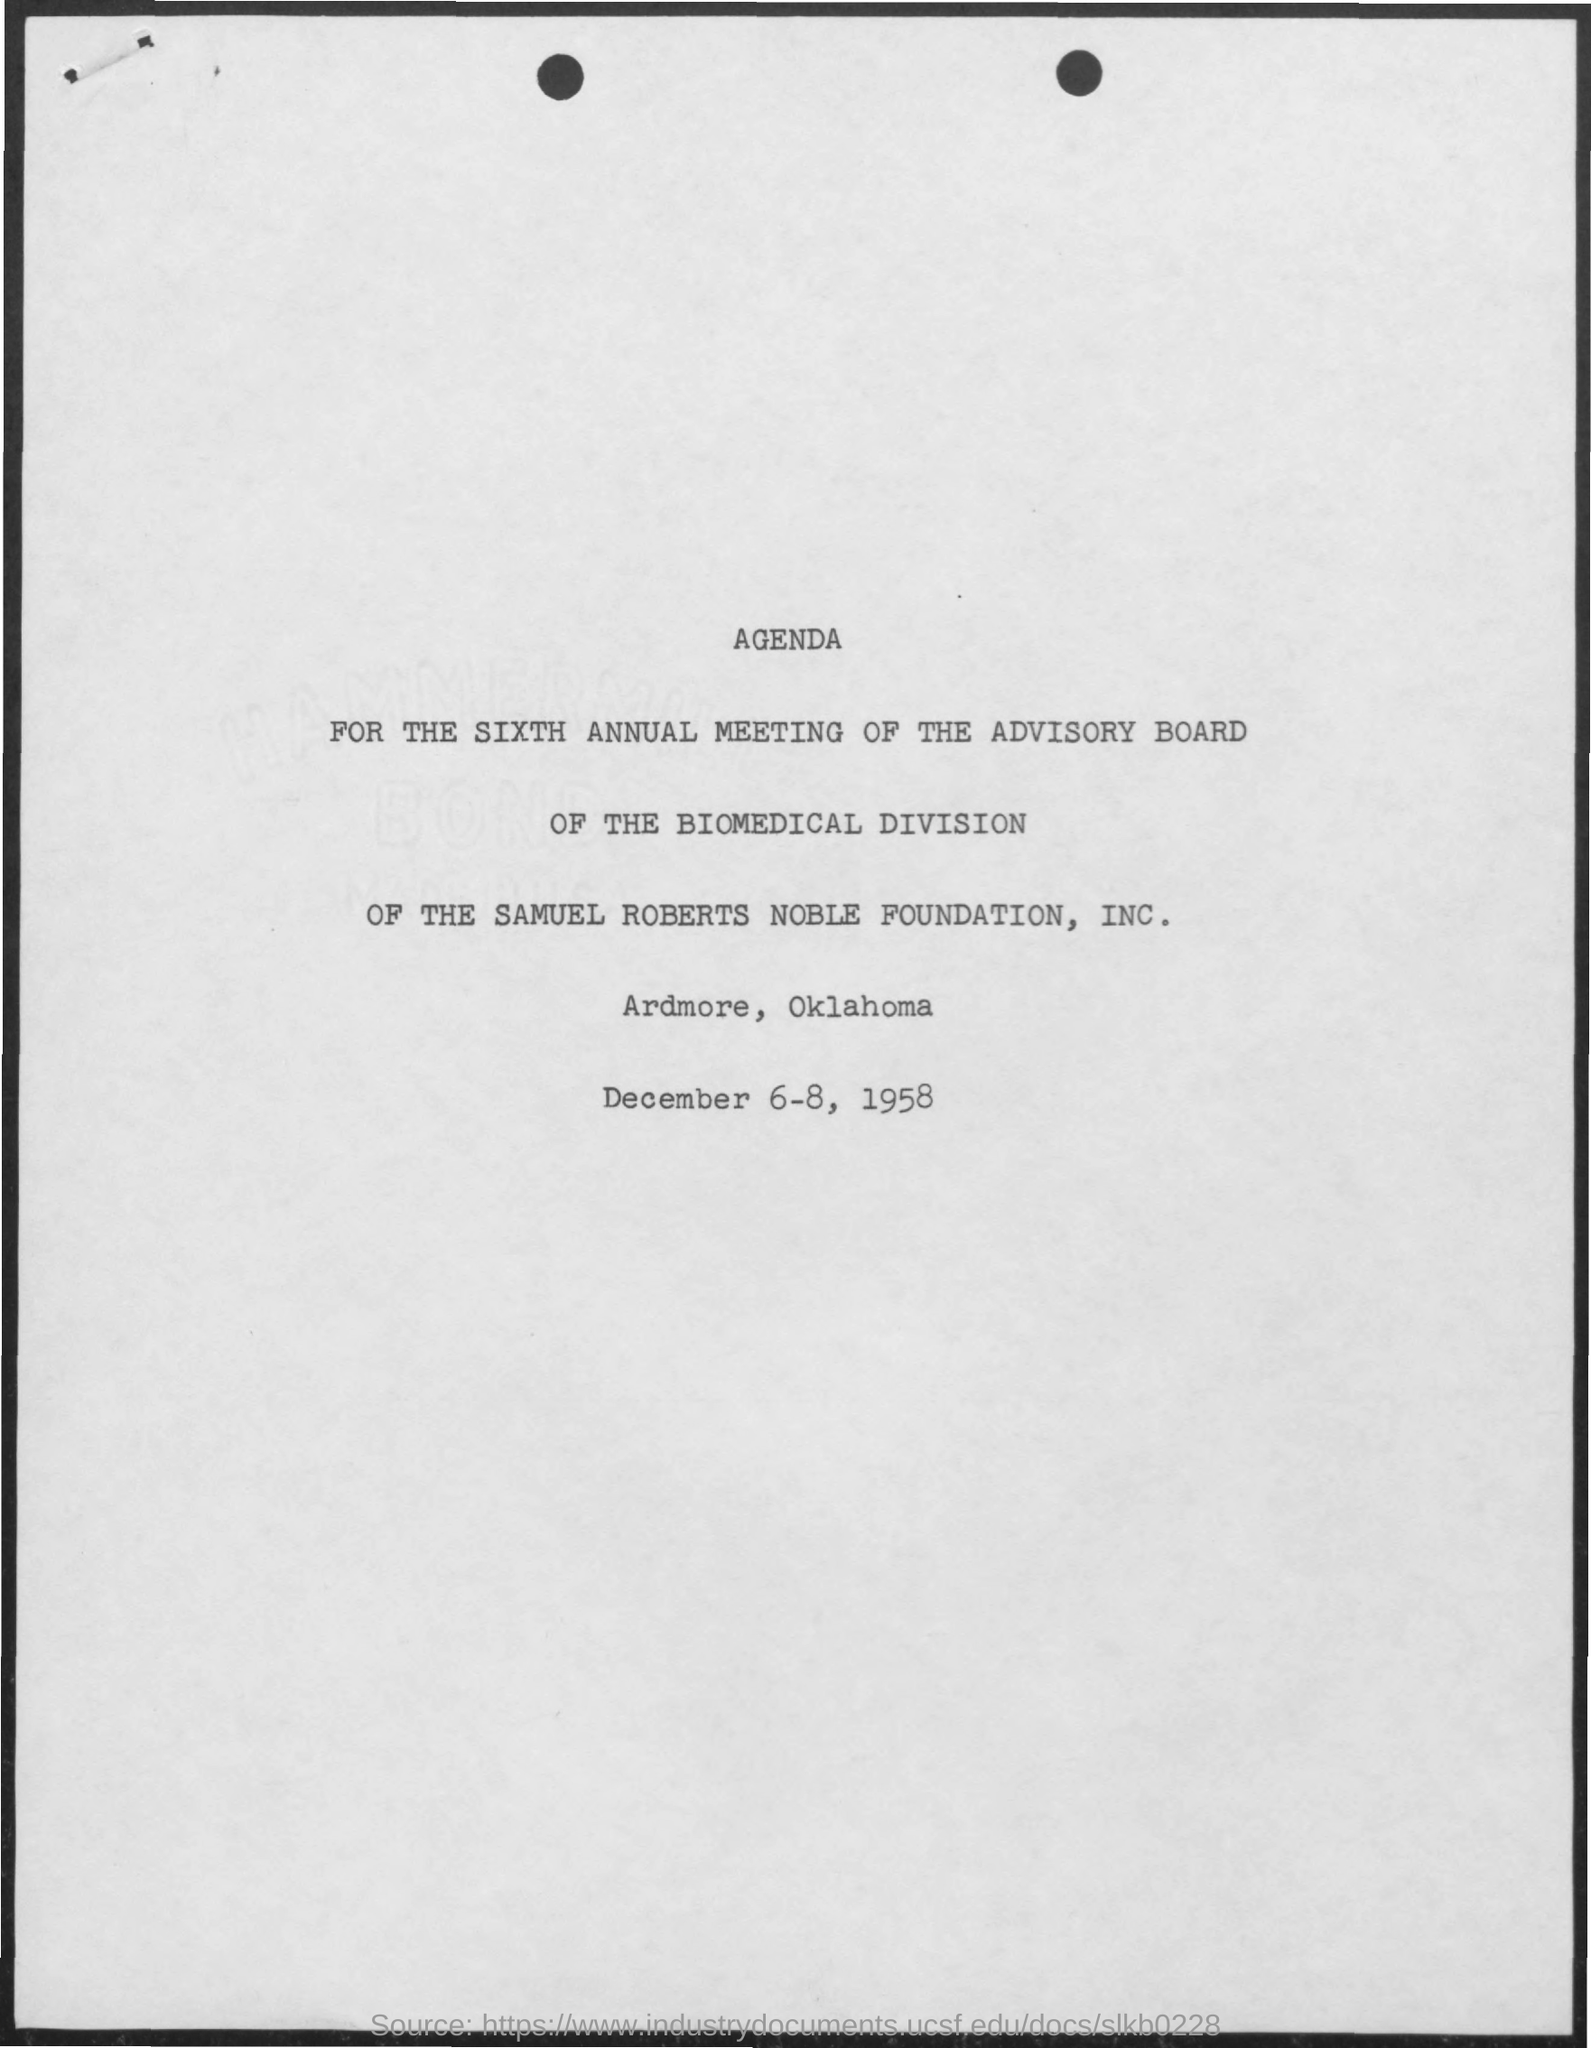List a handful of essential elements in this visual. The date mentioned in the given page is December 6-8, 1958. The Samuel Roberts Noble Foundation, Inc. is the name of the foundation mentioned. The biomedical division is a division mentioned in the given page. 